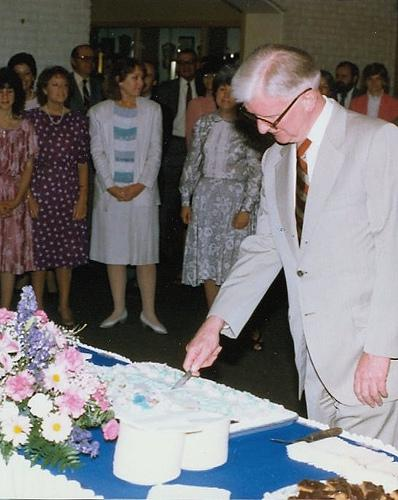Question: what is the man in front of the cake doing?
Choices:
A. Cutting the cake.
B. Eating the cake.
C. Laughing.
D. Crying.
Answer with the letter. Answer: A Question: where is the man with the knife?
Choices:
A. In front of the cake.
B. To the left of the cake.
C. To the right of the cake.
D. Behind the cake.
Answer with the letter. Answer: A Question: where are the flowers?
Choices:
A. Behind the cake.
B. To the left of the cake.
C. To the right of the cake.
D. In front of the cake.
Answer with the letter. Answer: A Question: where is the woman in the striped shirt?
Choices:
A. In front of the woman in polka dots.
B. Behind the woman in polka dots.
C. Next to the woman in polka dots.
D. Next to the woman in plaid.
Answer with the letter. Answer: C Question: how many buttons are buttoned on the jacket of the man cutting the cake?
Choices:
A. Two.
B. Three.
C. Four.
D. One.
Answer with the letter. Answer: D Question: what is the man cutting the cake wearing on his face?
Choices:
A. Glasses.
B. An eye patch.
C. A bandanna.
D. A scarf.
Answer with the letter. Answer: A Question: who is wearing a white jacket?
Choices:
A. Woman in plaid.
B. Woman in stripes.
C. Woman in polka dots.
D. Woman in solid shirt.
Answer with the letter. Answer: B Question: what color is the polka dot dress?
Choices:
A. Purple.
B. Red.
C. Yellow.
D. Black.
Answer with the letter. Answer: A 